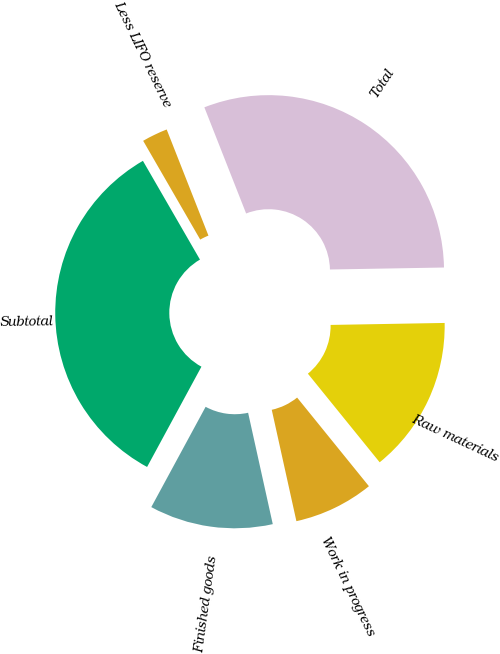Convert chart. <chart><loc_0><loc_0><loc_500><loc_500><pie_chart><fcel>Raw materials<fcel>Work in progress<fcel>Finished goods<fcel>Subtotal<fcel>Less LIFO reserve<fcel>Total<nl><fcel>14.44%<fcel>7.37%<fcel>11.37%<fcel>33.76%<fcel>2.37%<fcel>30.69%<nl></chart> 